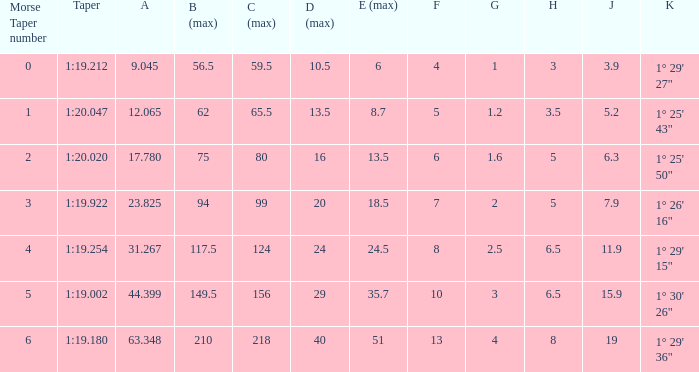Identify the smallest morse taper figure when the taper is 1:2 1.0. 